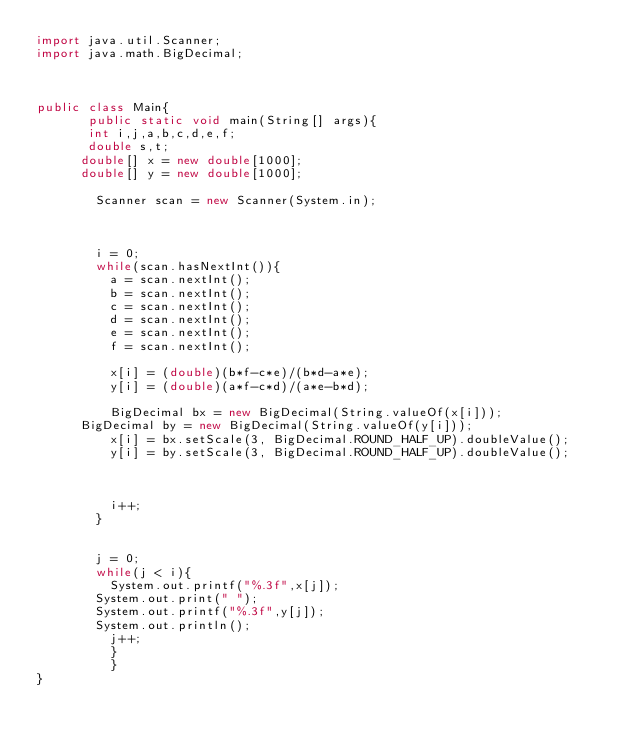Convert code to text. <code><loc_0><loc_0><loc_500><loc_500><_Java_>import java.util.Scanner;
import java.math.BigDecimal;



public class Main{
       public static void main(String[] args){
       int i,j,a,b,c,d,e,f;
       double s,t;
    	double[] x = new double[1000];
    	double[] y = new double[1000];
    
        Scanner scan = new Scanner(System.in);
        

       
        i = 0;
        while(scan.hasNextInt()){
        	a = scan.nextInt();
        	b = scan.nextInt();
        	c = scan.nextInt();
        	d = scan.nextInt();
        	e = scan.nextInt();
        	f = scan.nextInt();
        	
        	x[i] = (double)(b*f-c*e)/(b*d-a*e);
        	y[i] = (double)(a*f-c*d)/(a*e-b*d);
        	
        	BigDecimal bx = new BigDecimal(String.valueOf(x[i]));
			BigDecimal by = new BigDecimal(String.valueOf(y[i]));
        	x[i] = bx.setScale(3, BigDecimal.ROUND_HALF_UP).doubleValue();
        	y[i] = by.setScale(3, BigDecimal.ROUND_HALF_UP).doubleValue();

        	
     		
        	i++;
        }
      
        
        j = 0;
        while(j < i){
        	System.out.printf("%.3f",x[j]);
     		System.out.print(" ");
     		System.out.printf("%.3f",y[j]);
     		System.out.println();
        	j++;
       		}
       		}
}</code> 